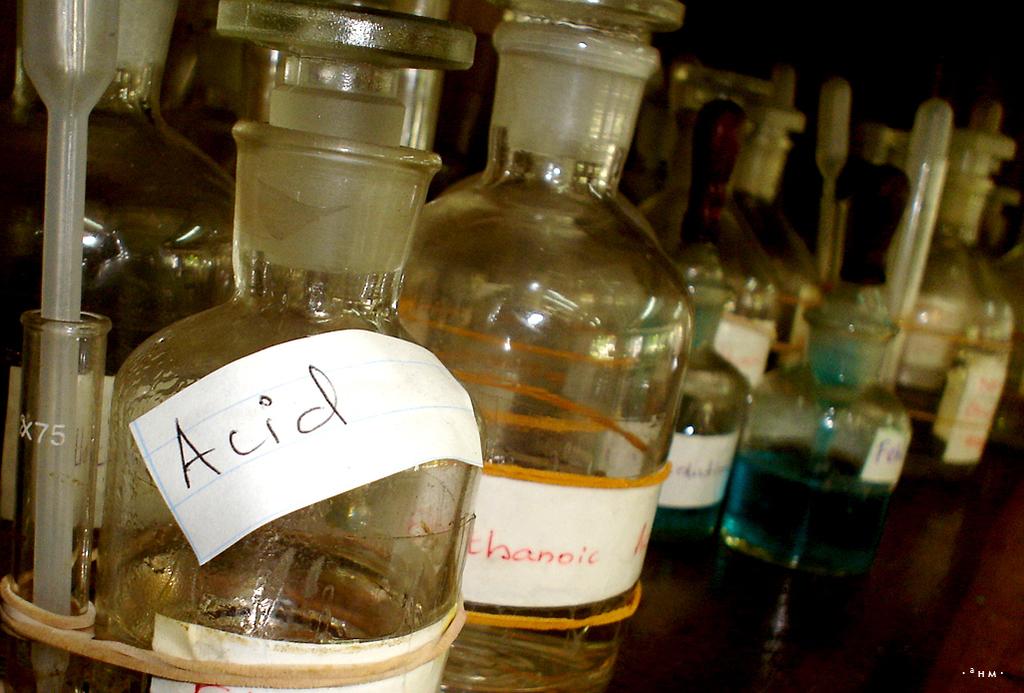What is in the bottle?
Provide a short and direct response. Acid. What is the color of the liquid on the right botte?
Provide a short and direct response. Answering does not require reading text in the image. 